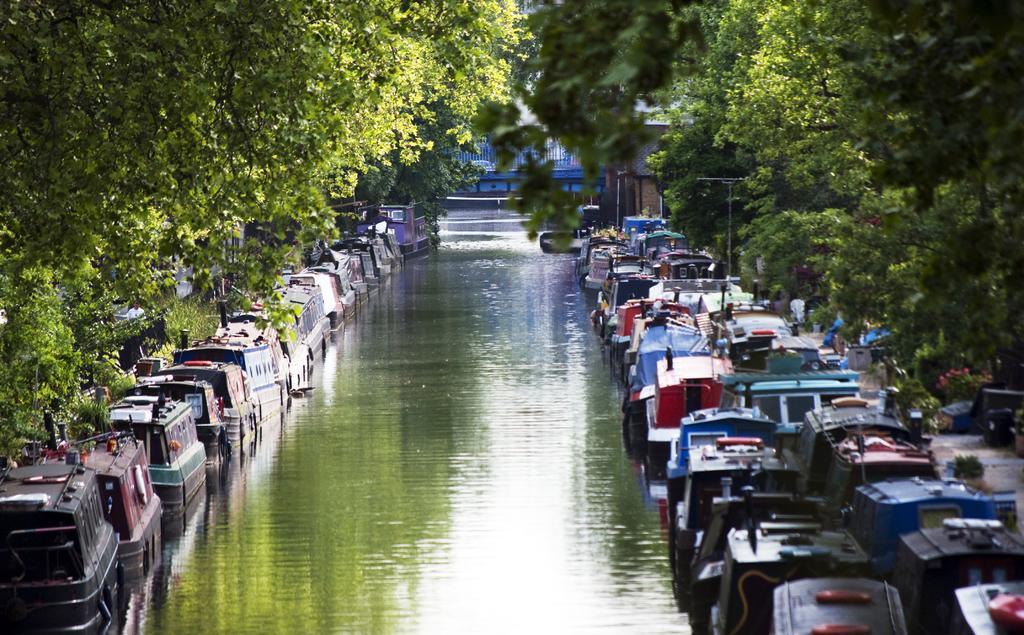How would you summarize this image in a sentence or two? In this image I can see canal boats on the water. There are trees on the either sides. 